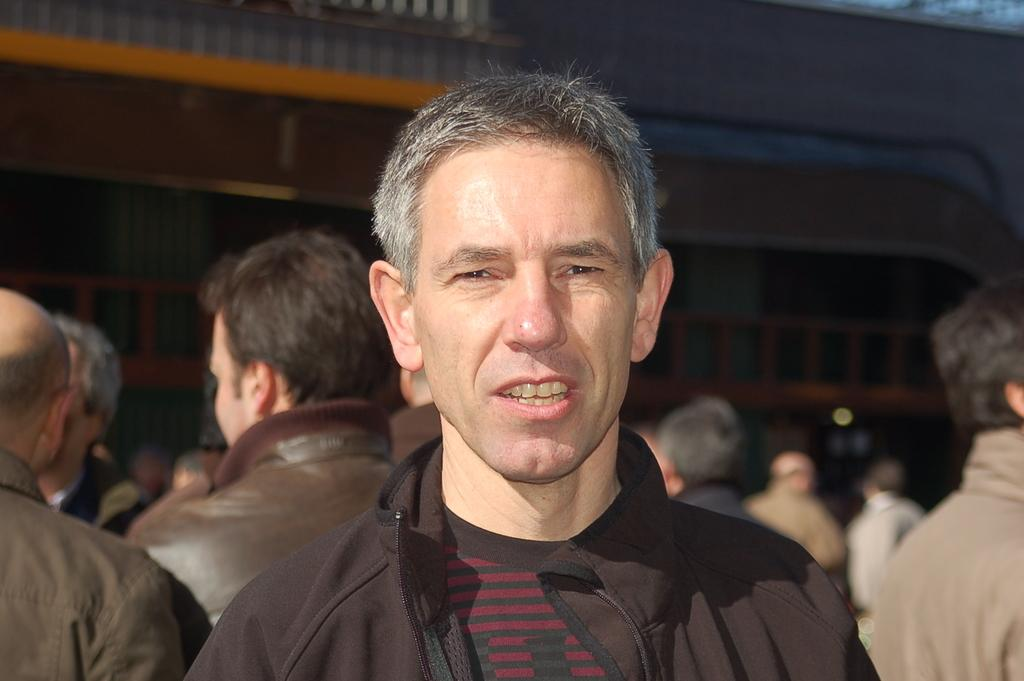Who is the main subject in the front of the image? There is a man in the front of the image. What can be observed about the man's facial expression? The man has an expression on his face. What else can be seen in the background of the image? There are persons and a building in the background of the image. What type of badge is the man wearing in the middle of the image? There is no mention of a badge in the image, and the man is not wearing one. 